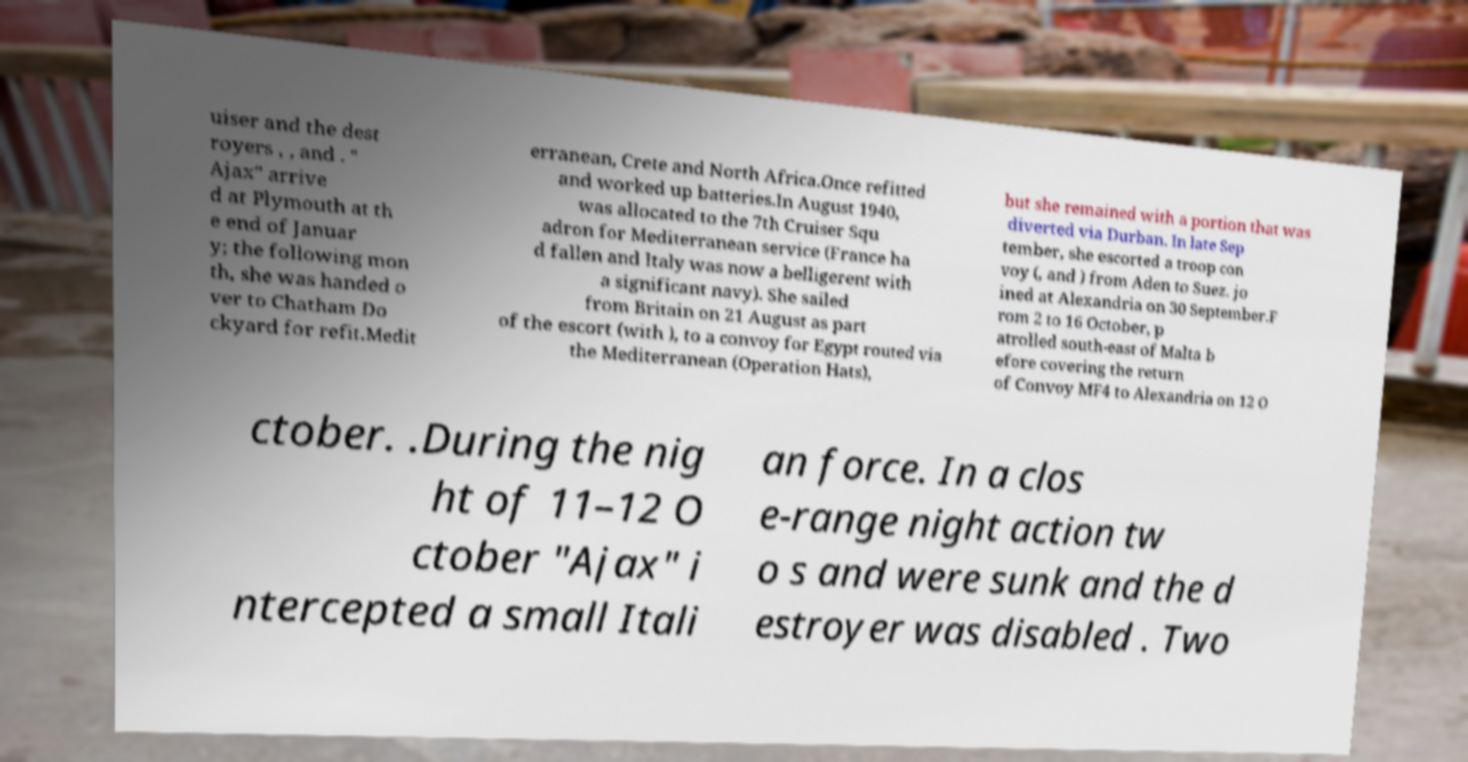Can you read and provide the text displayed in the image?This photo seems to have some interesting text. Can you extract and type it out for me? uiser and the dest royers , , and . " Ajax" arrive d at Plymouth at th e end of Januar y; the following mon th, she was handed o ver to Chatham Do ckyard for refit.Medit erranean, Crete and North Africa.Once refitted and worked up batteries.In August 1940, was allocated to the 7th Cruiser Squ adron for Mediterranean service (France ha d fallen and Italy was now a belligerent with a significant navy). She sailed from Britain on 21 August as part of the escort (with ), to a convoy for Egypt routed via the Mediterranean (Operation Hats), but she remained with a portion that was diverted via Durban. In late Sep tember, she escorted a troop con voy (, and ) from Aden to Suez. jo ined at Alexandria on 30 September.F rom 2 to 16 October, p atrolled south-east of Malta b efore covering the return of Convoy MF4 to Alexandria on 12 O ctober. .During the nig ht of 11–12 O ctober "Ajax" i ntercepted a small Itali an force. In a clos e-range night action tw o s and were sunk and the d estroyer was disabled . Two 